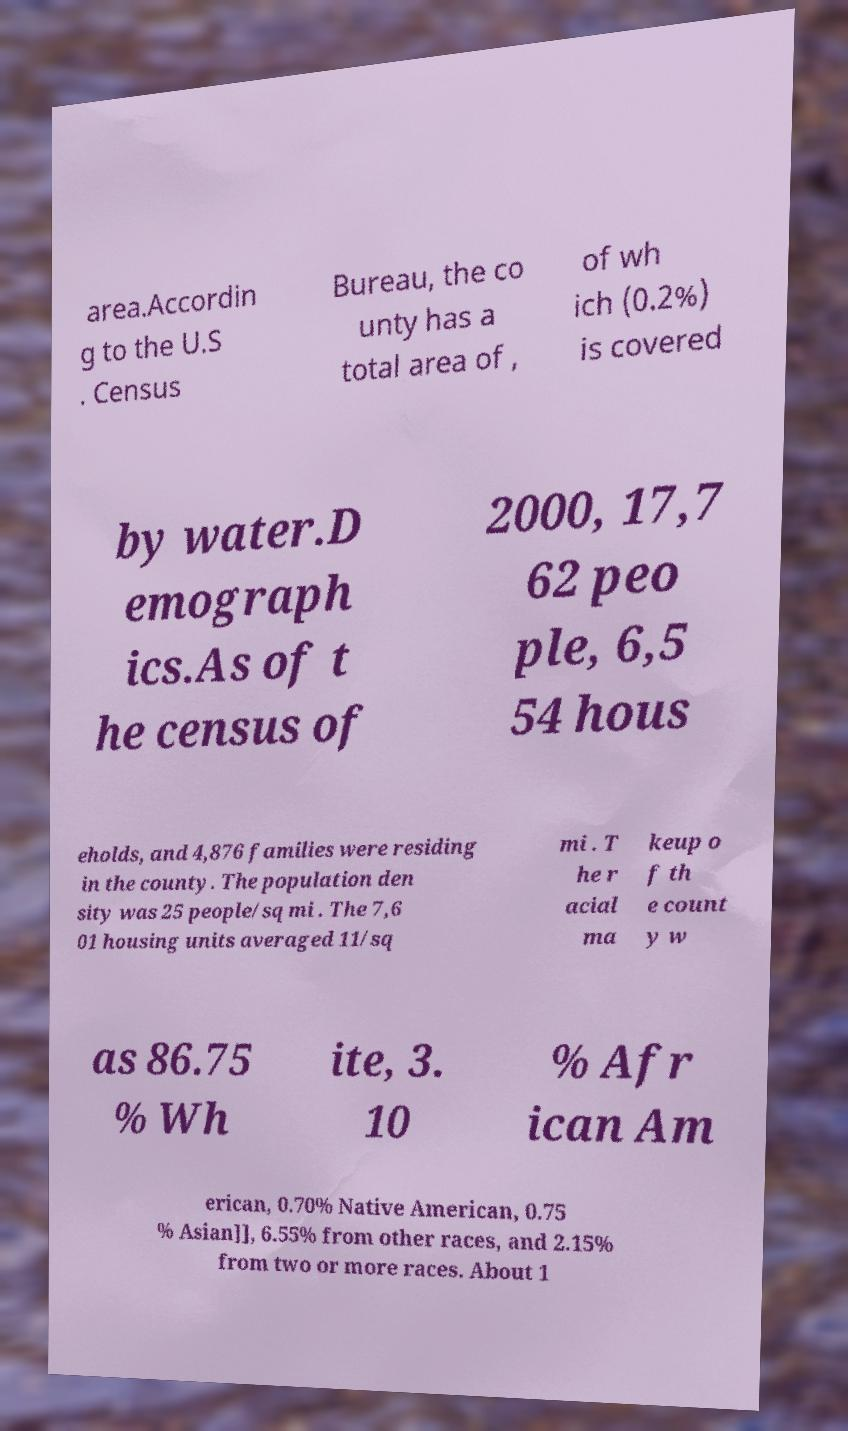Can you accurately transcribe the text from the provided image for me? area.Accordin g to the U.S . Census Bureau, the co unty has a total area of , of wh ich (0.2%) is covered by water.D emograph ics.As of t he census of 2000, 17,7 62 peo ple, 6,5 54 hous eholds, and 4,876 families were residing in the county. The population den sity was 25 people/sq mi . The 7,6 01 housing units averaged 11/sq mi . T he r acial ma keup o f th e count y w as 86.75 % Wh ite, 3. 10 % Afr ican Am erican, 0.70% Native American, 0.75 % Asian]], 6.55% from other races, and 2.15% from two or more races. About 1 